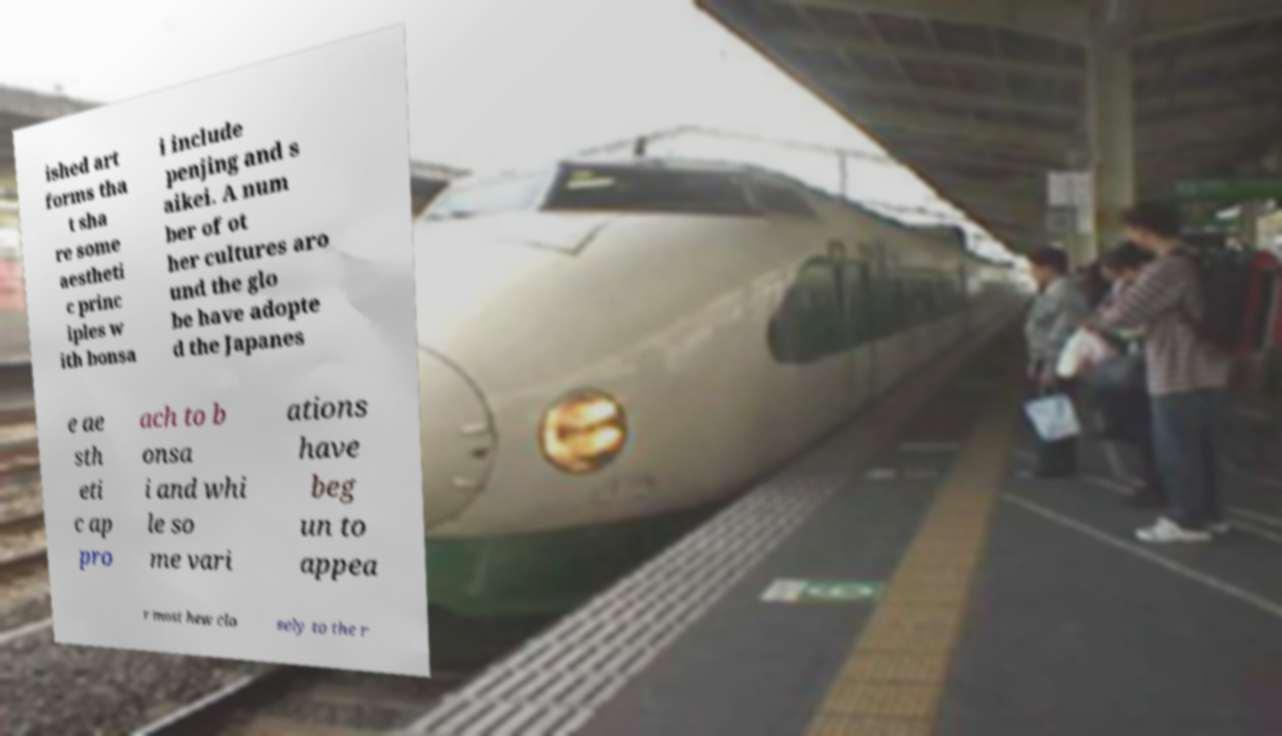Can you read and provide the text displayed in the image?This photo seems to have some interesting text. Can you extract and type it out for me? ished art forms tha t sha re some aestheti c princ iples w ith bonsa i include penjing and s aikei. A num ber of ot her cultures aro und the glo be have adopte d the Japanes e ae sth eti c ap pro ach to b onsa i and whi le so me vari ations have beg un to appea r most hew clo sely to the r 